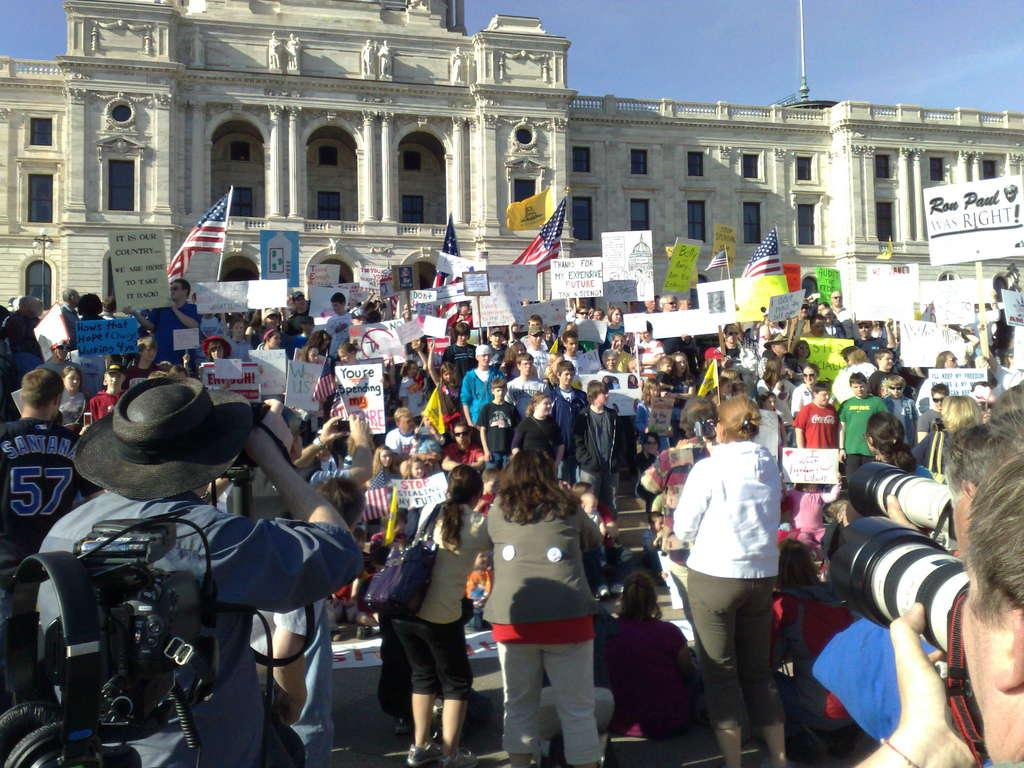How many people are in the image? There is a group of people in the image. What are the people doing in the image? The people are standing, holding placards, flags, and cameras. What can be seen in the background of the image? There is a building and the sky visible in the background of the image. What type of honey is being collected by the boy with a hammer in the image? There is no boy or hammer present in the image, and therefore no honey collection is taking place. 